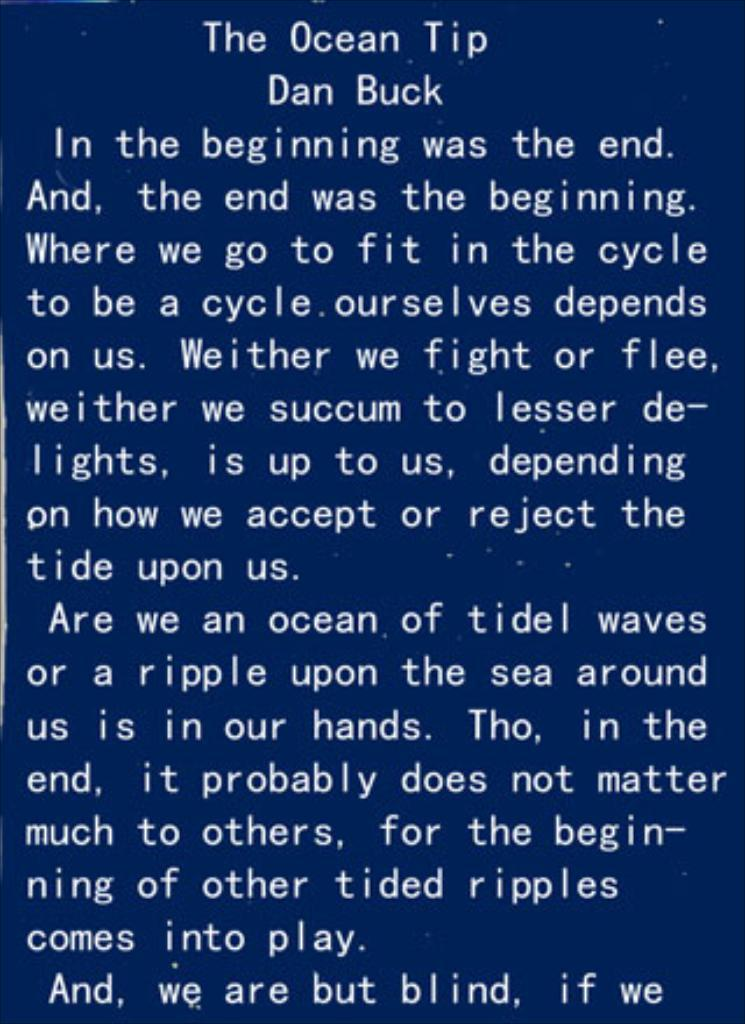<image>
Describe the image concisely. Page of writing from Dan Buck on the Ocean Tip Story line. 